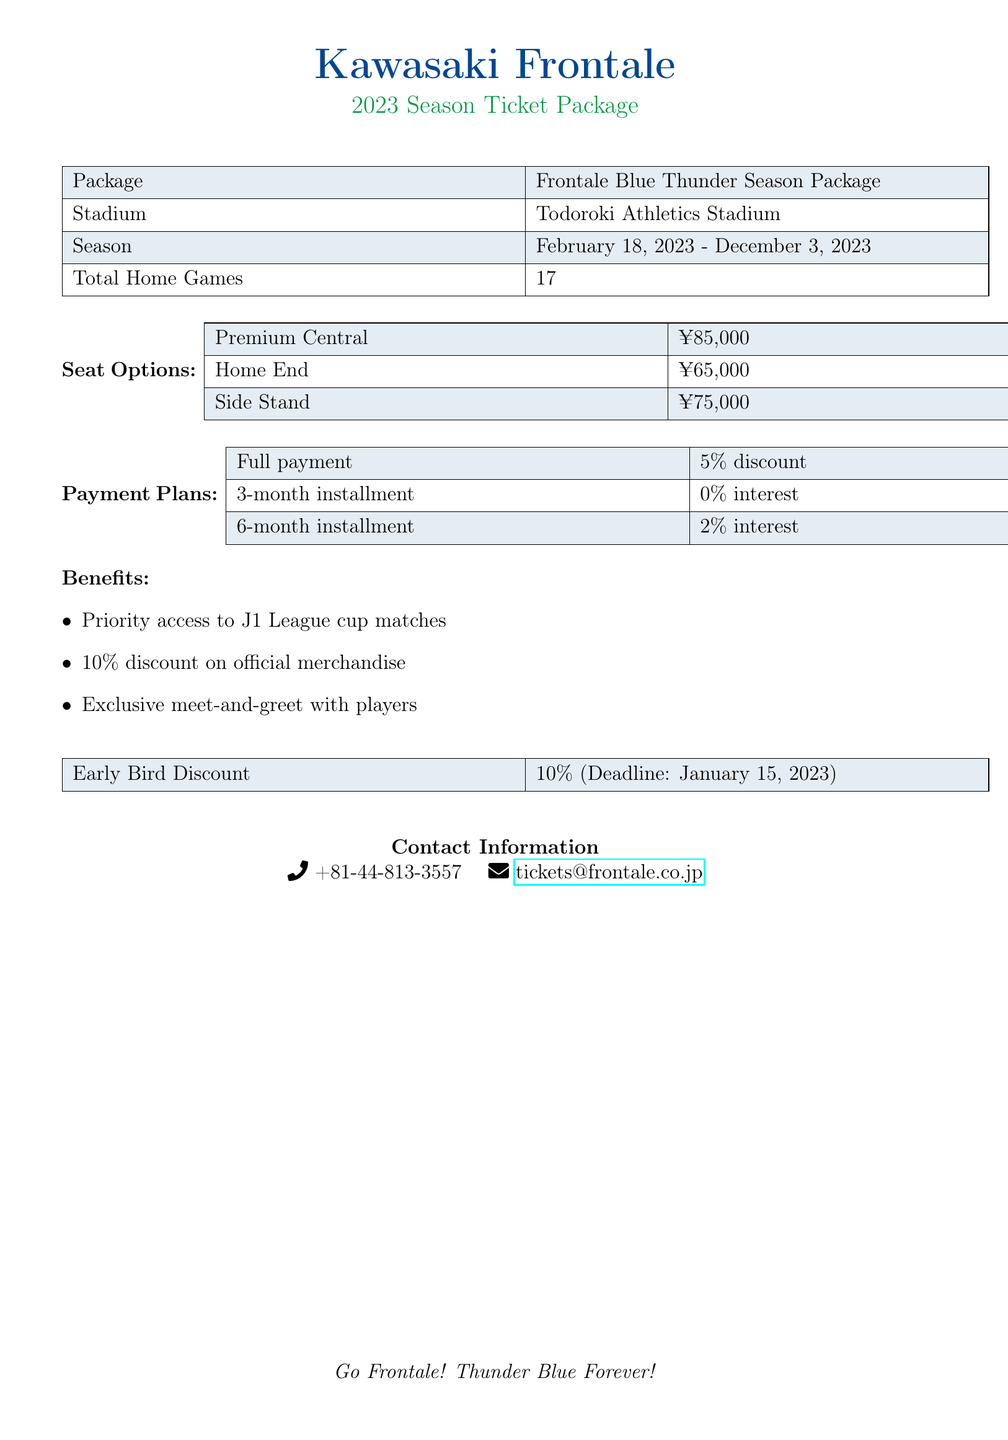What is the package name? The package name is listed as "Frontale Blue Thunder Season Package" in the document.
Answer: Frontale Blue Thunder Season Package How many total home games are there? The document states that there are a total of 17 home games for the season.
Answer: 17 What is the price of a Premium Central seat? The price for a Premium Central seat is provided in the seat options section of the document.
Answer: ¥85,000 What is the early bird discount percentage? The document specifies that the early bird discount is 10%.
Answer: 10% What is the deadline for the early bird discount? The deadline for the early bird discount is noted in the benefits section of the document.
Answer: January 15, 2023 What payment plan has a 5% discount? The document indicates that full payment qualifies for a 5% discount.
Answer: Full payment How long is the season? The season dates are provided in the document, showing when it starts and ends.
Answer: February 18, 2023 - December 3, 2023 What benefit includes a discount on merchandise? The document lists a 10% discount on official merchandise as one of the benefits.
Answer: 10% discount on official merchandise What is the contact phone number? The document provides a specific phone number for contact regarding tickets.
Answer: +81-44-813-3557 